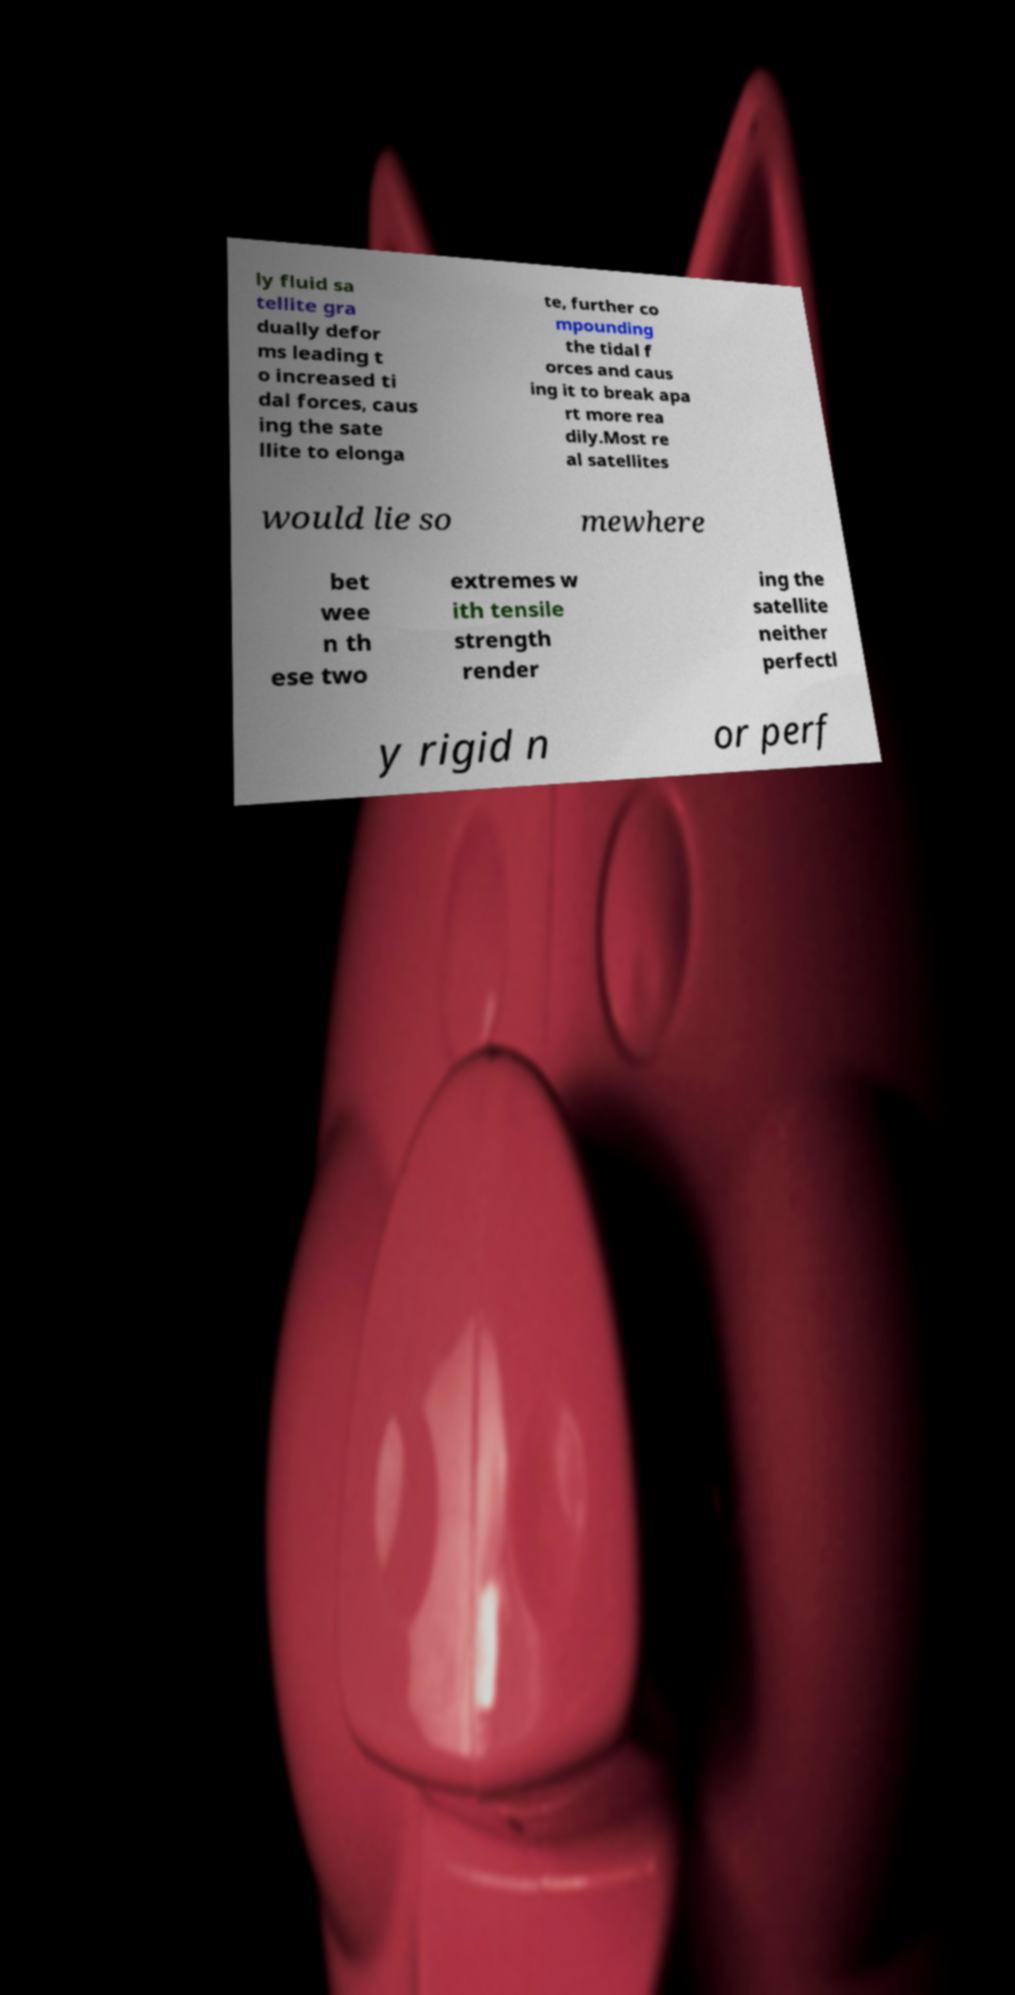There's text embedded in this image that I need extracted. Can you transcribe it verbatim? ly fluid sa tellite gra dually defor ms leading t o increased ti dal forces, caus ing the sate llite to elonga te, further co mpounding the tidal f orces and caus ing it to break apa rt more rea dily.Most re al satellites would lie so mewhere bet wee n th ese two extremes w ith tensile strength render ing the satellite neither perfectl y rigid n or perf 